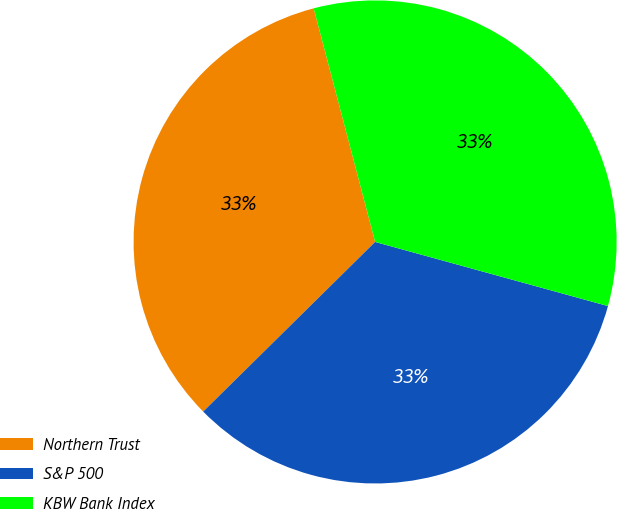<chart> <loc_0><loc_0><loc_500><loc_500><pie_chart><fcel>Northern Trust<fcel>S&P 500<fcel>KBW Bank Index<nl><fcel>33.3%<fcel>33.33%<fcel>33.37%<nl></chart> 